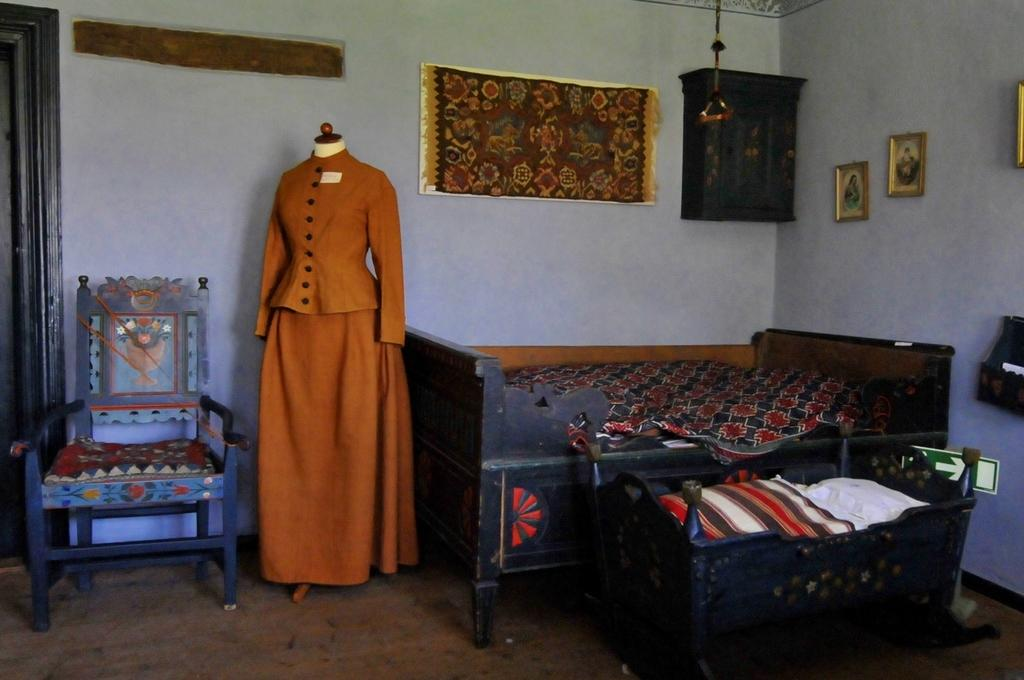What is displayed on the mannequin in the image? There is a dress on a mannequin in the image. What piece of furniture is located to the left of the mannequin? There is a chair to the left of the mannequin. What type of furniture is to the right of the mannequin? There is a bed to the right of the mannequin. What object is also to the right of the mannequin? There is a basket to the right of the mannequin. What can be seen on the wall in the background of the image? There are frames on the wall in the background of the image. What type of scarf is the authority figure wearing in the image? There is no authority figure or scarf present in the image. 